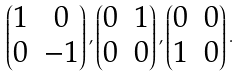<formula> <loc_0><loc_0><loc_500><loc_500>\begin{pmatrix} 1 & 0 \\ 0 & - 1 \end{pmatrix} , \begin{pmatrix} 0 & 1 \\ 0 & 0 \end{pmatrix} , \begin{pmatrix} 0 & 0 \\ 1 & 0 \end{pmatrix} .</formula> 